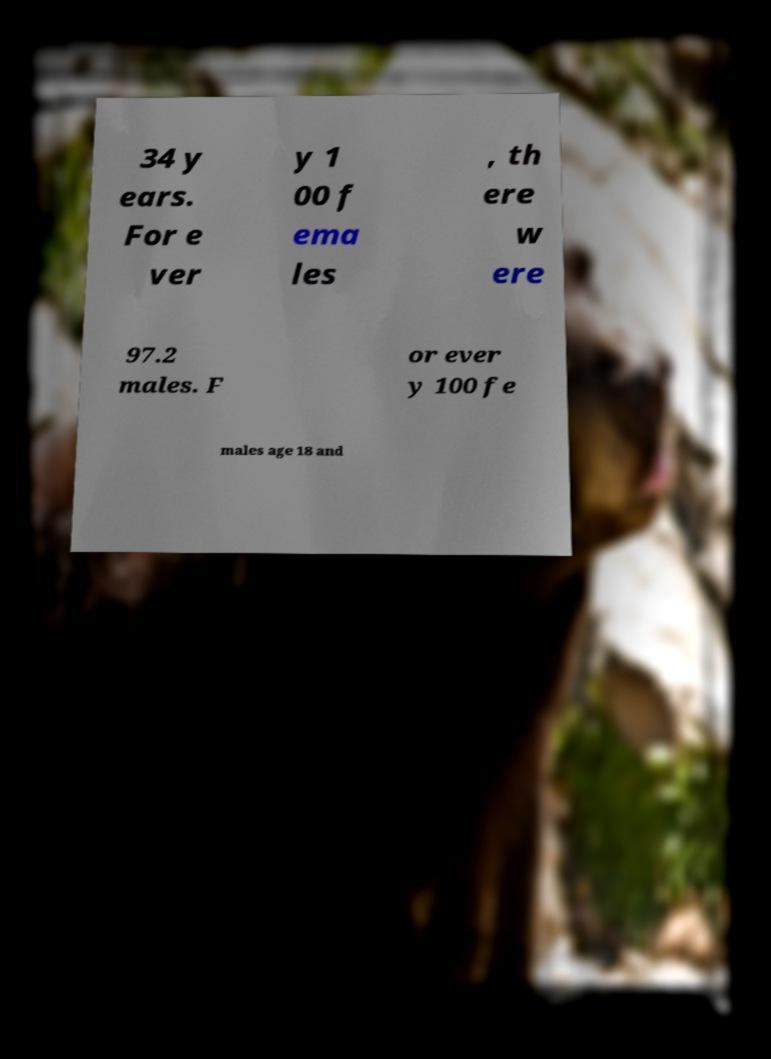Could you extract and type out the text from this image? 34 y ears. For e ver y 1 00 f ema les , th ere w ere 97.2 males. F or ever y 100 fe males age 18 and 